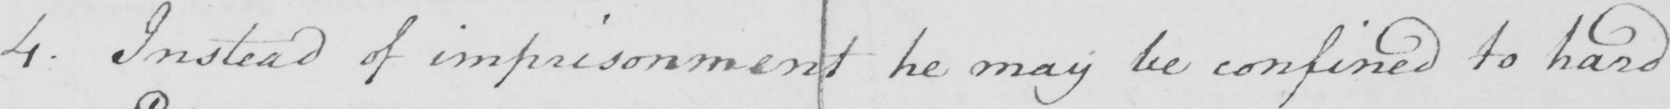Can you tell me what this handwritten text says? 4 . Instead of imprisonment he may be confined to hard 